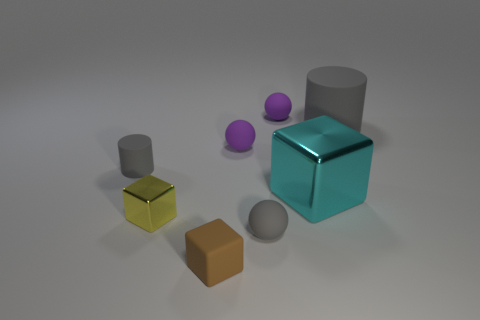Subtract all purple matte balls. How many balls are left? 1 Add 2 gray spheres. How many objects exist? 10 Subtract 2 spheres. How many spheres are left? 1 Subtract all purple spheres. How many spheres are left? 1 Subtract all cubes. How many objects are left? 5 Subtract all cyan spheres. How many blue blocks are left? 0 Subtract all tiny blocks. Subtract all tiny rubber things. How many objects are left? 1 Add 5 brown rubber things. How many brown rubber things are left? 6 Add 8 small yellow things. How many small yellow things exist? 9 Subtract 1 cyan blocks. How many objects are left? 7 